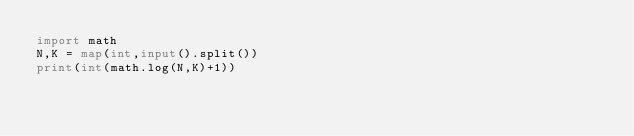Convert code to text. <code><loc_0><loc_0><loc_500><loc_500><_Python_>import math
N,K = map(int,input().split())
print(int(math.log(N,K)+1))
</code> 